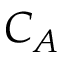Convert formula to latex. <formula><loc_0><loc_0><loc_500><loc_500>C _ { A }</formula> 